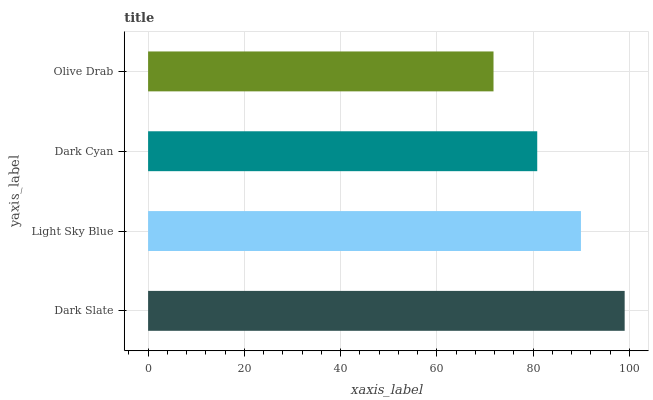Is Olive Drab the minimum?
Answer yes or no. Yes. Is Dark Slate the maximum?
Answer yes or no. Yes. Is Light Sky Blue the minimum?
Answer yes or no. No. Is Light Sky Blue the maximum?
Answer yes or no. No. Is Dark Slate greater than Light Sky Blue?
Answer yes or no. Yes. Is Light Sky Blue less than Dark Slate?
Answer yes or no. Yes. Is Light Sky Blue greater than Dark Slate?
Answer yes or no. No. Is Dark Slate less than Light Sky Blue?
Answer yes or no. No. Is Light Sky Blue the high median?
Answer yes or no. Yes. Is Dark Cyan the low median?
Answer yes or no. Yes. Is Dark Cyan the high median?
Answer yes or no. No. Is Olive Drab the low median?
Answer yes or no. No. 